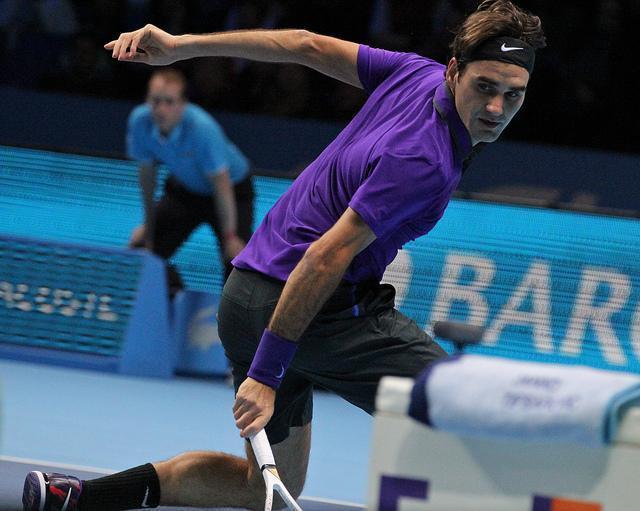How many people are there?
Give a very brief answer. 2. How many baby elephants are in the picture?
Give a very brief answer. 0. 